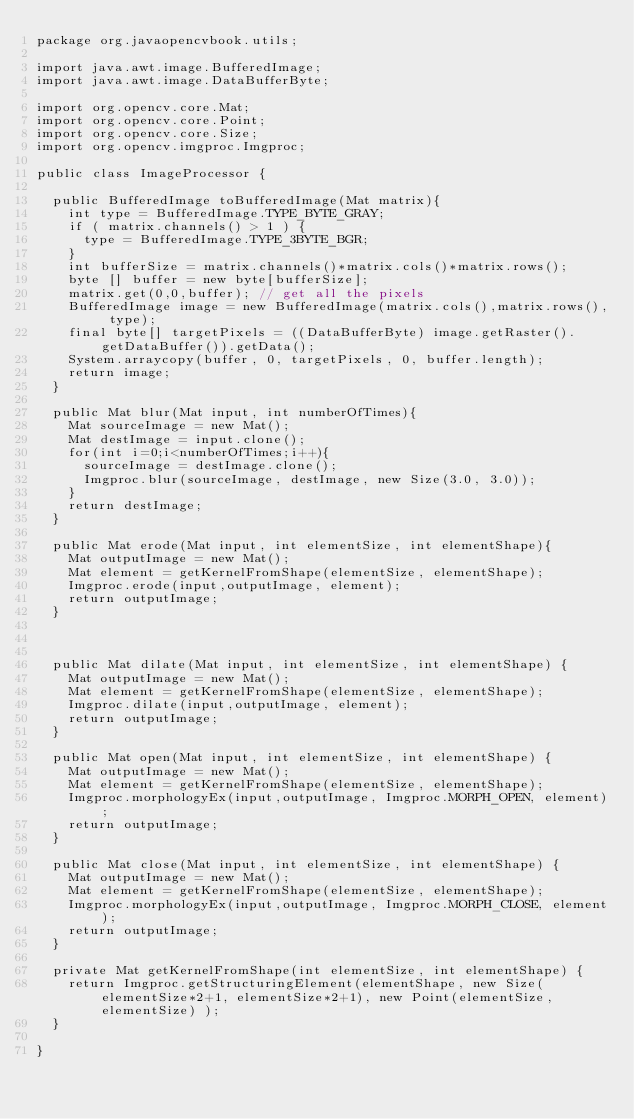Convert code to text. <code><loc_0><loc_0><loc_500><loc_500><_Java_>package org.javaopencvbook.utils;

import java.awt.image.BufferedImage;
import java.awt.image.DataBufferByte;

import org.opencv.core.Mat;
import org.opencv.core.Point;
import org.opencv.core.Size;
import org.opencv.imgproc.Imgproc;

public class ImageProcessor {
	
	public BufferedImage toBufferedImage(Mat matrix){
		int type = BufferedImage.TYPE_BYTE_GRAY;
		if ( matrix.channels() > 1 ) {
			type = BufferedImage.TYPE_3BYTE_BGR;
		}
		int bufferSize = matrix.channels()*matrix.cols()*matrix.rows();
		byte [] buffer = new byte[bufferSize];
		matrix.get(0,0,buffer); // get all the pixels
		BufferedImage image = new BufferedImage(matrix.cols(),matrix.rows(), type);
		final byte[] targetPixels = ((DataBufferByte) image.getRaster().getDataBuffer()).getData();
		System.arraycopy(buffer, 0, targetPixels, 0, buffer.length);  
		return image;
	}
	
	public Mat blur(Mat input, int numberOfTimes){
		Mat sourceImage = new Mat();
		Mat destImage = input.clone();
		for(int i=0;i<numberOfTimes;i++){
			sourceImage = destImage.clone();
			Imgproc.blur(sourceImage, destImage, new Size(3.0, 3.0));
		}
		return destImage;
	}
	
	public Mat erode(Mat input, int elementSize, int elementShape){
		Mat outputImage = new Mat();
		Mat element = getKernelFromShape(elementSize, elementShape);
		Imgproc.erode(input,outputImage, element);
		return outputImage;
	}

	

	public Mat dilate(Mat input, int elementSize, int elementShape) {
		Mat outputImage = new Mat();
		Mat element = getKernelFromShape(elementSize, elementShape);
		Imgproc.dilate(input,outputImage, element);
		return outputImage;
	}

	public Mat open(Mat input, int elementSize, int elementShape) {
		Mat outputImage = new Mat();
		Mat element = getKernelFromShape(elementSize, elementShape);
		Imgproc.morphologyEx(input,outputImage, Imgproc.MORPH_OPEN, element);
		return outputImage;
	}

	public Mat close(Mat input, int elementSize, int elementShape) {
		Mat outputImage = new Mat();
		Mat element = getKernelFromShape(elementSize, elementShape);
		Imgproc.morphologyEx(input,outputImage, Imgproc.MORPH_CLOSE, element);
		return outputImage;
	}
	
	private Mat getKernelFromShape(int elementSize, int elementShape) {
		return Imgproc.getStructuringElement(elementShape, new Size(elementSize*2+1, elementSize*2+1), new Point(elementSize, elementSize) );
	}

}
</code> 